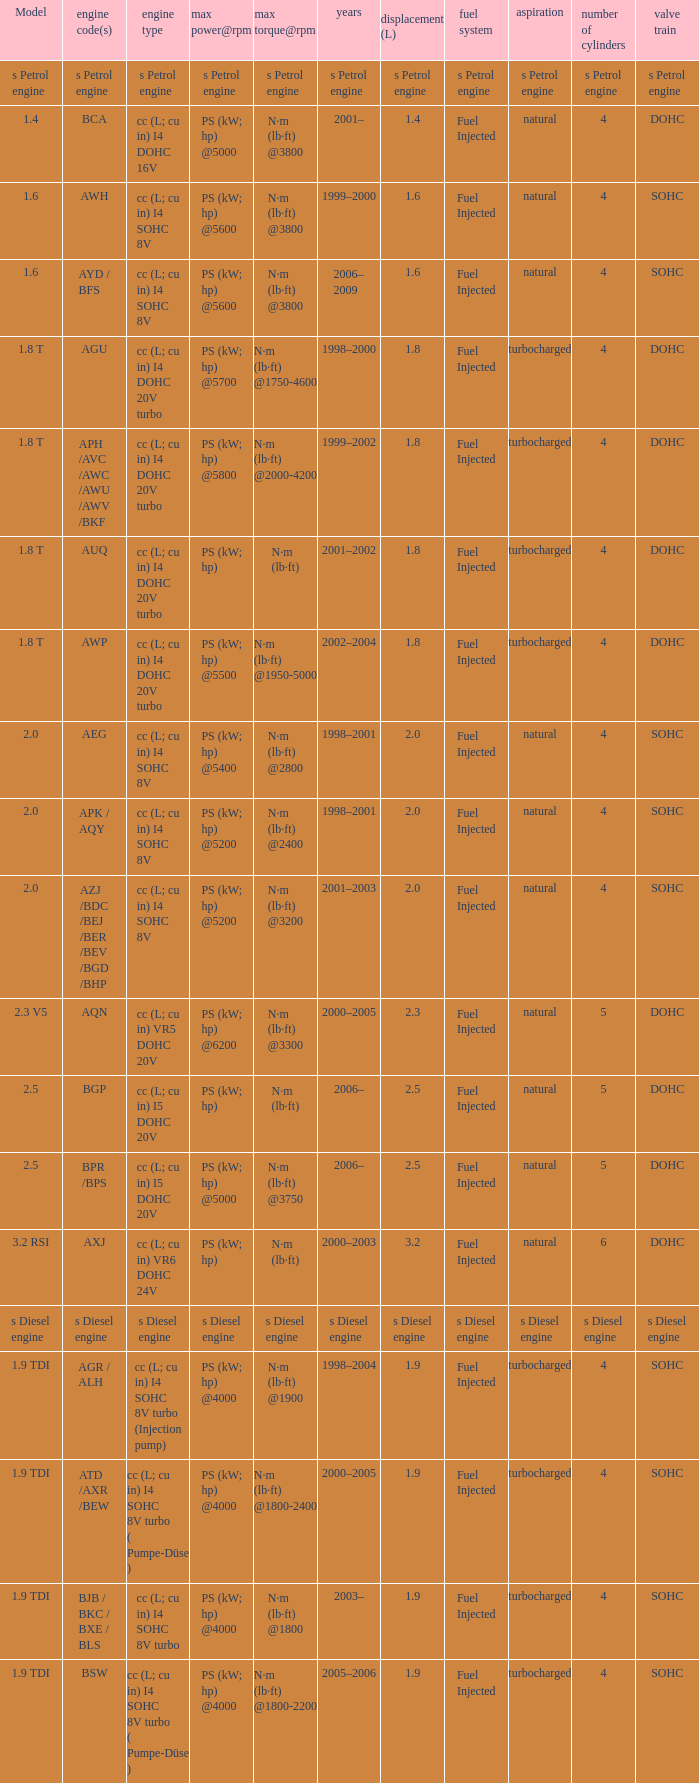What was the max torque@rpm of the engine which had the model 2.5  and a max power@rpm of ps (kw; hp) @5000? N·m (lb·ft) @3750. 